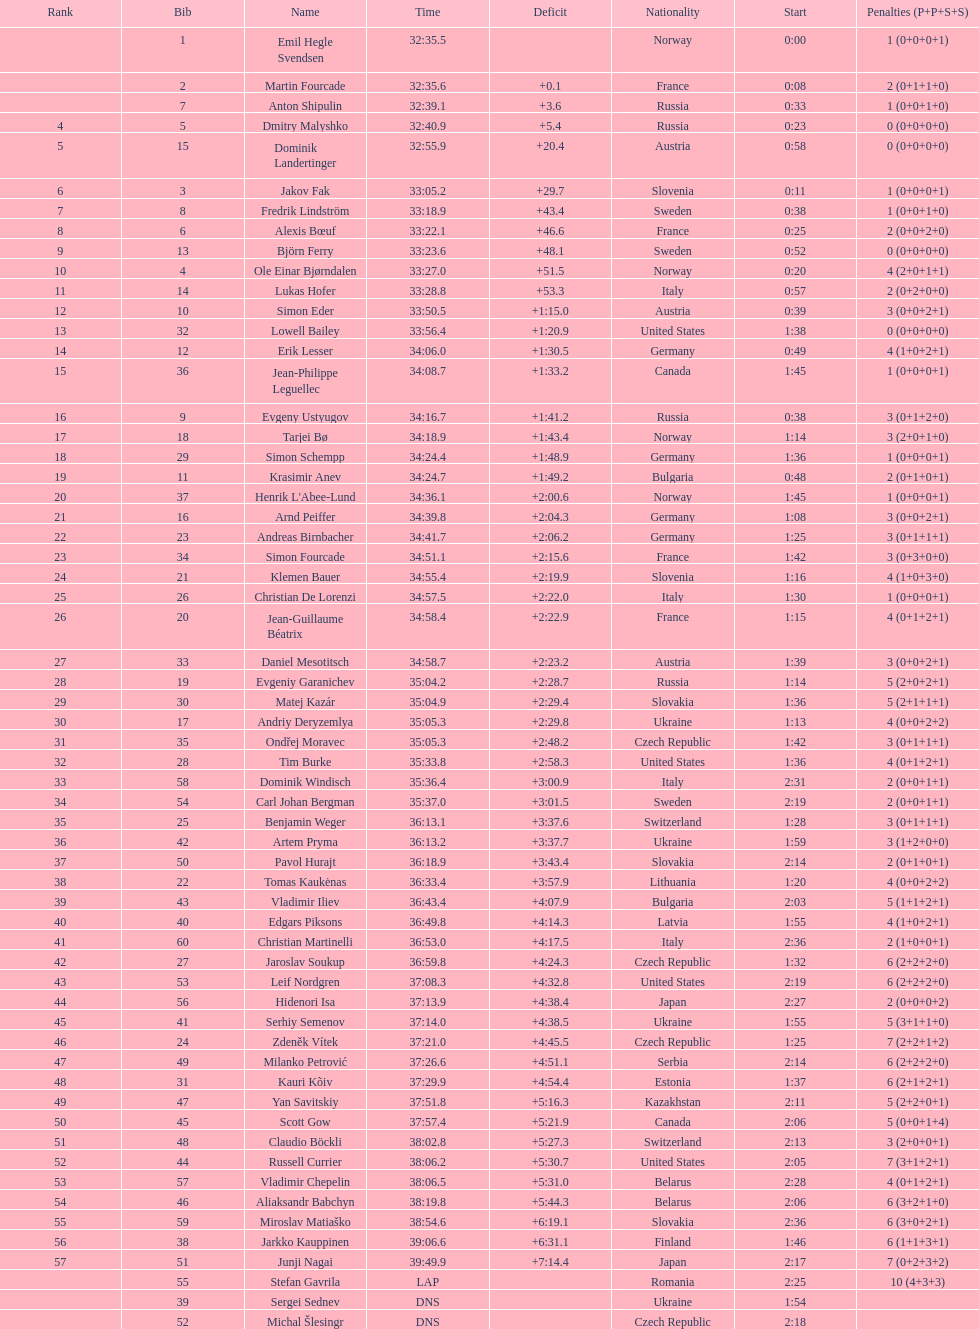Who holds the highest ranking among swedish runners? Fredrik Lindström. 